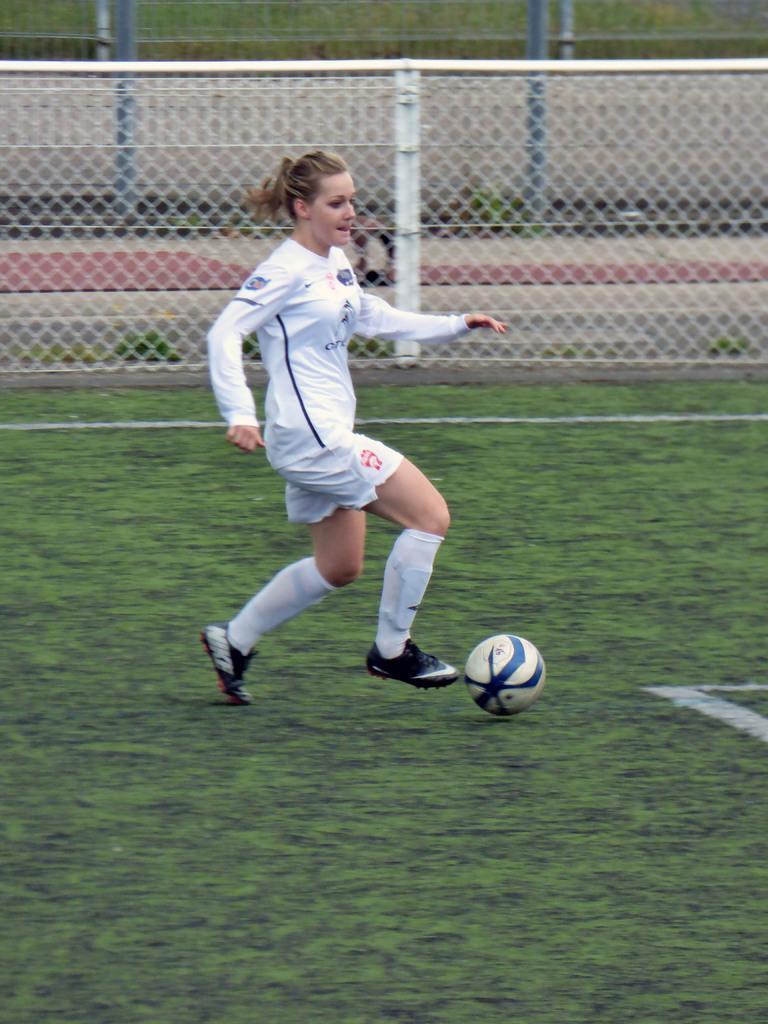How would you summarize this image in a sentence or two? A woman football player is kicking the ball in a match. 